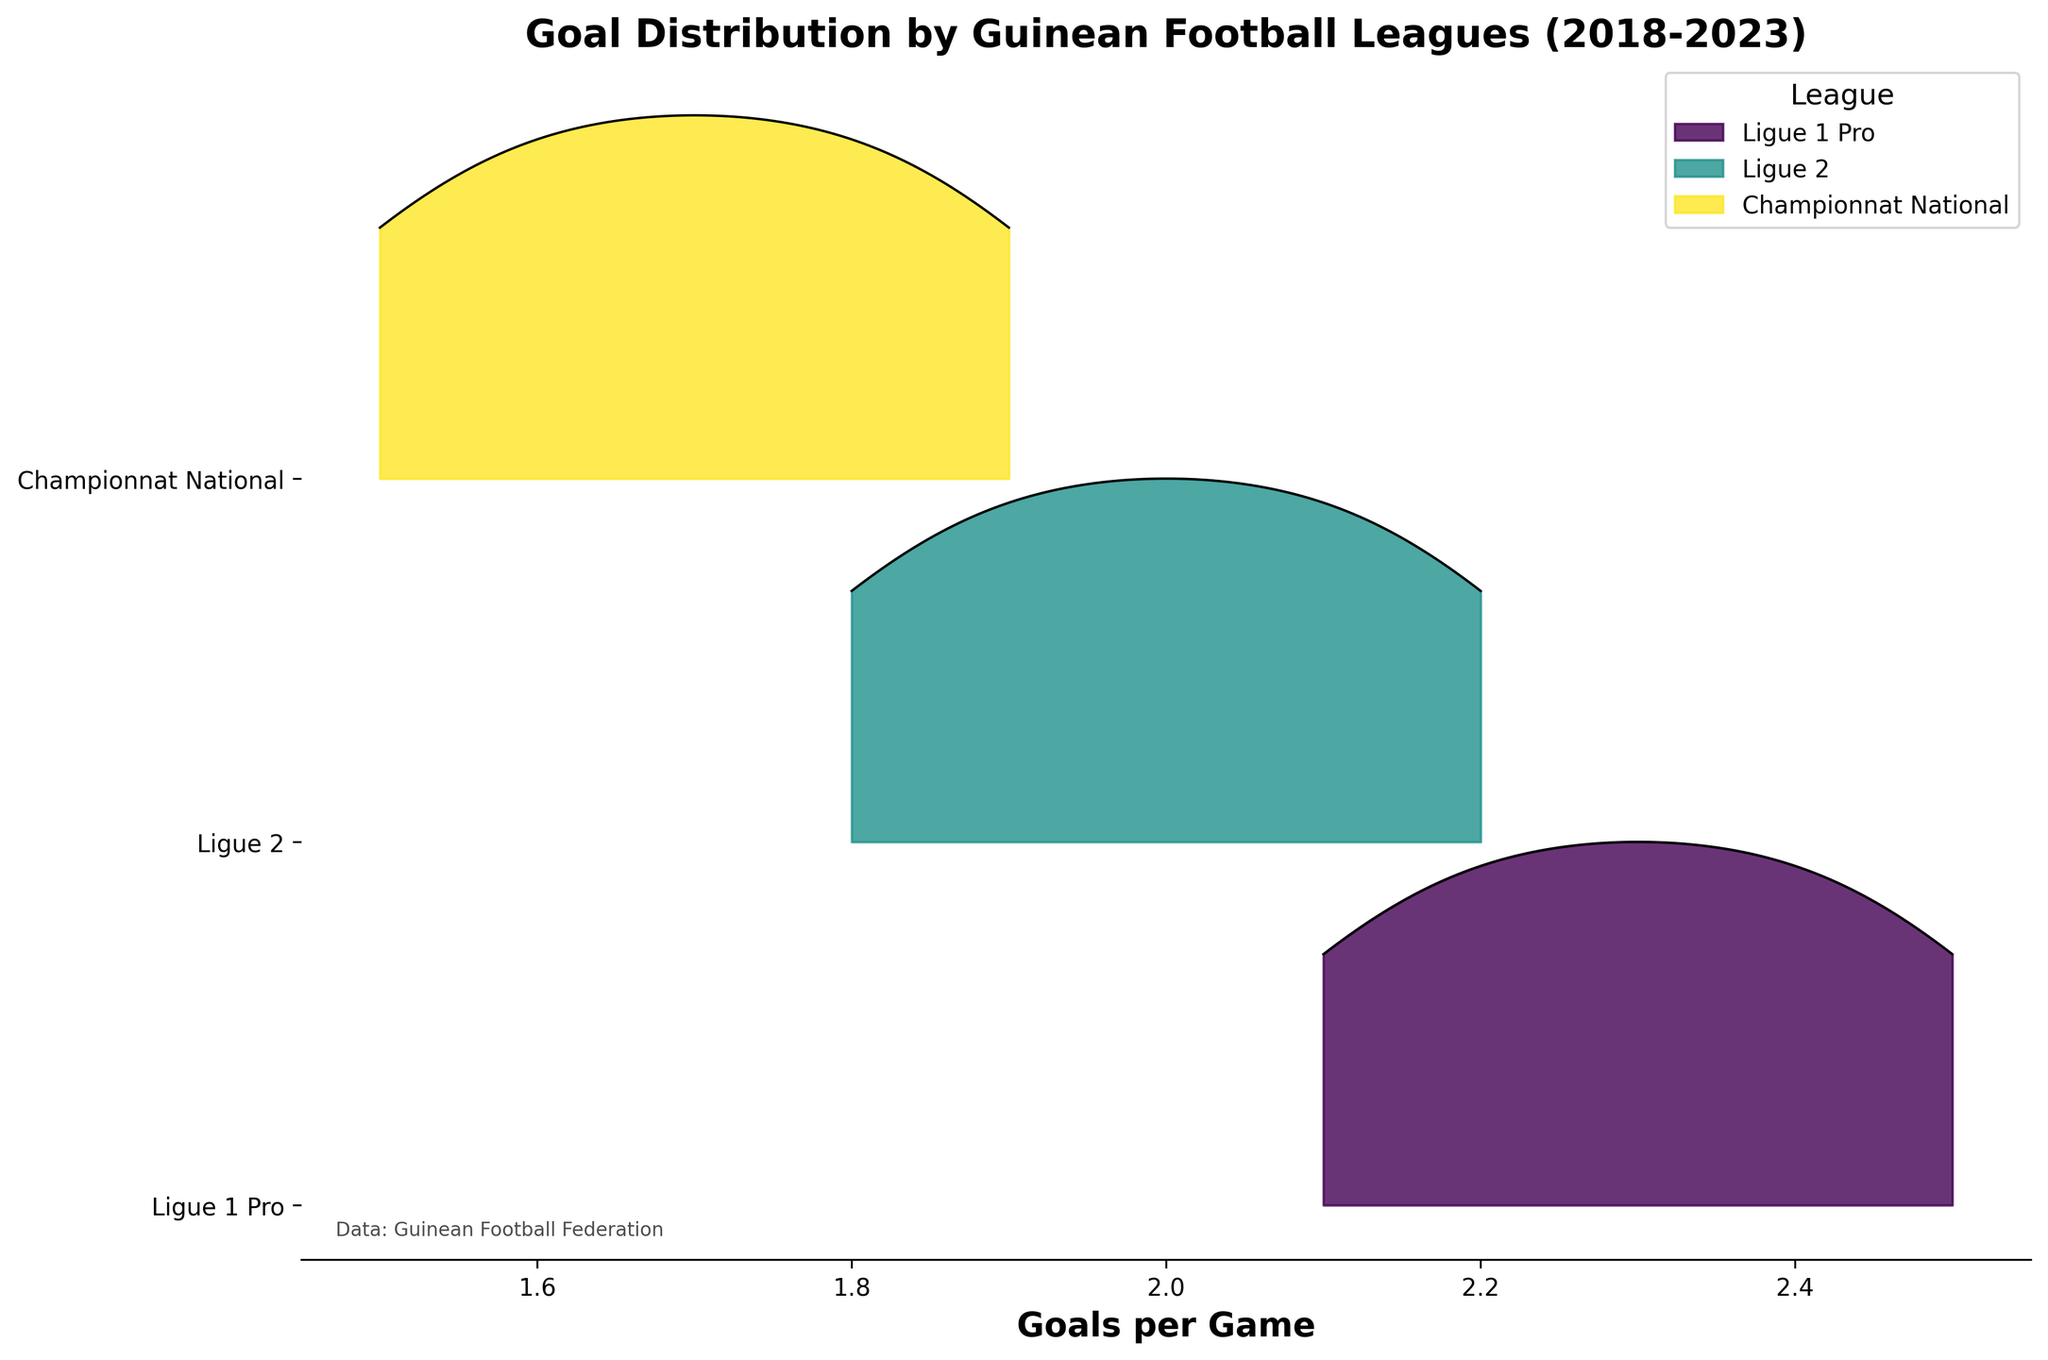Which league had the highest goals per game in the 2022-23 season? Looking at the rightmost points of the ridgeline plot, Ligue 1 Pro had the highest goals per game with 2.5.
Answer: Ligue 1 Pro What is the main title of the plot? The main title is at the top of the plot. It reads "Goal Distribution by Guinean Football Leagues (2018-2023)".
Answer: Goal Distribution by Guinean Football Leagues (2018-2023) How do the goal distributions of Ligue 1 Pro and Championnat National compare across the 5 seasons? Comparing the highest peaks, Ligue 1 Pro consistently shows higher goals per game. Championnat National starts lower and increases gradually but does not reach Ligue 1 Pro levels.
Answer: Ligue 1 Pro has higher goal distributions Which league showed the most steady increase in goals per game over the seasons? Looking at the upward trend lines, Championnat National shows the most steady increase, moving from 1.5 in 2018-19 to 1.9 in 2022-23.
Answer: Championnat National How many leagues are represented in the plot? The y-axis lists the leagues. There are three leagues: Ligue 1 Pro, Ligue 2, and Championnat National.
Answer: Three What is the range of the goals per game for Ligue 2 across the seasons? The x-axis range of Ligue 2 spans from about 1.8 in 2018-19 to 2.2 in 2022-23.
Answer: 1.8 to 2.2 Which season had the lowest average goals per game across all leagues? Looking for the lowest points on the ridgeline plot, the 2018-19 season had the lowest values, with Championnat National at 1.5 and Ligue 2 at 1.8.
Answer: 2018-19 What is the color used to represent Ligue 1 Pro in the plot? Observing the colors of the ridgeline distributions, Ligue 1 Pro is represented by the color at the topmost portion.
Answer: The specific color isn't defined in natural language here, but it's distinct atop Between Ligue 1 Pro and Ligue 2, which one had a higher variance in goals per game? Evaluating the width of the distribution curves, Ligue 1 Pro shows a slightly higher range and variability in goals per game compared to Ligue 2.
Answer: Ligue 1 Pro 